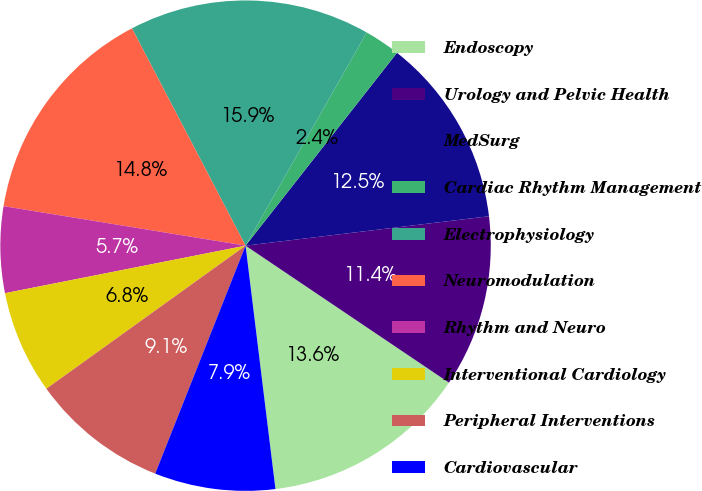Convert chart to OTSL. <chart><loc_0><loc_0><loc_500><loc_500><pie_chart><fcel>Endoscopy<fcel>Urology and Pelvic Health<fcel>MedSurg<fcel>Cardiac Rhythm Management<fcel>Electrophysiology<fcel>Neuromodulation<fcel>Rhythm and Neuro<fcel>Interventional Cardiology<fcel>Peripheral Interventions<fcel>Cardiovascular<nl><fcel>13.62%<fcel>11.35%<fcel>12.49%<fcel>2.37%<fcel>15.89%<fcel>14.76%<fcel>5.68%<fcel>6.81%<fcel>9.08%<fcel>7.95%<nl></chart> 